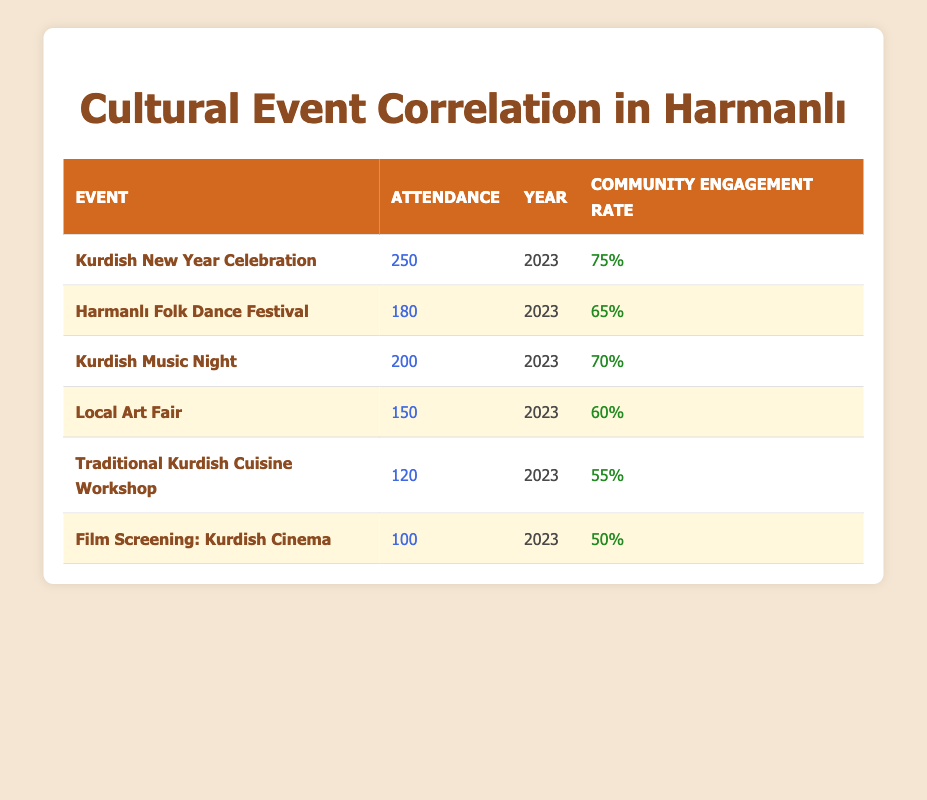What was the highest attendance of a cultural event in 2023? The table lists the attendance for each cultural event in 2023. The highest attendance recorded is for the "Kurdish New Year Celebration" with 250 attendees.
Answer: 250 What is the community engagement rate for the "Local Art Fair"? The table shows that the "Local Art Fair" has a community engagement rate of 60%.
Answer: 60% Which event had the lowest attendance in 2023? By checking the attendance values in the table, "Film Screening: Kurdish Cinema" had the lowest attendance at 100.
Answer: 100 What is the average community engagement rate for all events listed? To find the average, sum the engagement rates: 0.75 + 0.65 + 0.70 + 0.60 + 0.55 + 0.50 = 3.25. Then divide by the number of events (6): 3.25 / 6 = approximately 0.542 or 54.2%.
Answer: 54.2% Is the attendance at the "Traditional Kurdish Cuisine Workshop" higher than the community engagement rate of the "Harmanlı Folk Dance Festival"? The attendance for the "Traditional Kurdish Cuisine Workshop" is 120 and the community engagement rate for the "Harmanlı Folk Dance Festival" is 65%. Since 120 is greater than 65, the statement is true.
Answer: Yes Do both "Kurdish Music Night" and "Local Art Fair" have community engagement rates above 60%? The community engagement rate for "Kurdish Music Night" is 70%, which is above 60%. However, the "Local Art Fair" has an engagement rate of 60%, which is not above 60%. Therefore, the answer is no.
Answer: No How many events have an attendance of less than 150? From the table, the events with less than 150 attendance are "Local Art Fair" (150), "Traditional Kurdish Cuisine Workshop" (120), and "Film Screening: Kurdish Cinema" (100). However, only "Traditional Kurdish Cuisine Workshop" and "Film Screening: Kurdish Cinema" fall under 150, making it two events total.
Answer: 2 What was the community engagement rate difference between the "Kurdish New Year Celebration" and the "Traditional Kurdish Cuisine Workshop"? The engagement rate for the "Kurdish New Year Celebration" is 0.75 and for the "Traditional Kurdish Cuisine Workshop" is 0.55. The difference is calculated as 0.75 - 0.55 = 0.20 or 20%.
Answer: 20% 